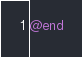Convert code to text. <code><loc_0><loc_0><loc_500><loc_500><_ObjectiveC_>
@end
</code> 